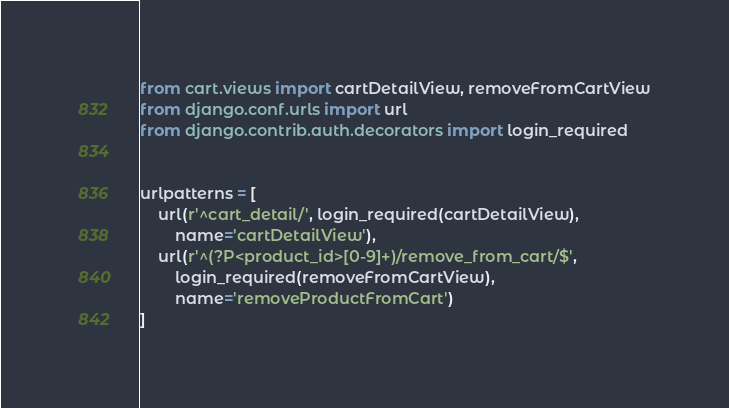Convert code to text. <code><loc_0><loc_0><loc_500><loc_500><_Python_>from cart.views import cartDetailView, removeFromCartView
from django.conf.urls import url
from django.contrib.auth.decorators import login_required


urlpatterns = [
    url(r'^cart_detail/', login_required(cartDetailView),
        name='cartDetailView'),
    url(r'^(?P<product_id>[0-9]+)/remove_from_cart/$',
        login_required(removeFromCartView),
        name='removeProductFromCart')
]
</code> 